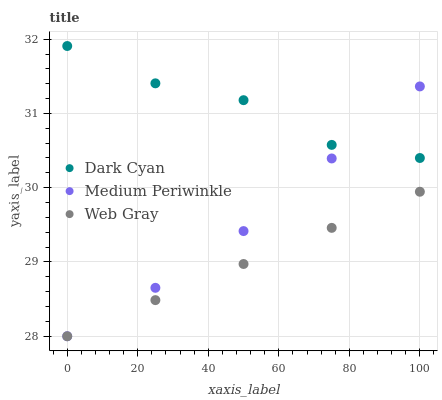Does Web Gray have the minimum area under the curve?
Answer yes or no. Yes. Does Dark Cyan have the maximum area under the curve?
Answer yes or no. Yes. Does Medium Periwinkle have the minimum area under the curve?
Answer yes or no. No. Does Medium Periwinkle have the maximum area under the curve?
Answer yes or no. No. Is Web Gray the smoothest?
Answer yes or no. Yes. Is Dark Cyan the roughest?
Answer yes or no. Yes. Is Medium Periwinkle the smoothest?
Answer yes or no. No. Is Medium Periwinkle the roughest?
Answer yes or no. No. Does Web Gray have the lowest value?
Answer yes or no. Yes. Does Dark Cyan have the highest value?
Answer yes or no. Yes. Does Medium Periwinkle have the highest value?
Answer yes or no. No. Is Web Gray less than Dark Cyan?
Answer yes or no. Yes. Is Dark Cyan greater than Web Gray?
Answer yes or no. Yes. Does Web Gray intersect Medium Periwinkle?
Answer yes or no. Yes. Is Web Gray less than Medium Periwinkle?
Answer yes or no. No. Is Web Gray greater than Medium Periwinkle?
Answer yes or no. No. Does Web Gray intersect Dark Cyan?
Answer yes or no. No. 